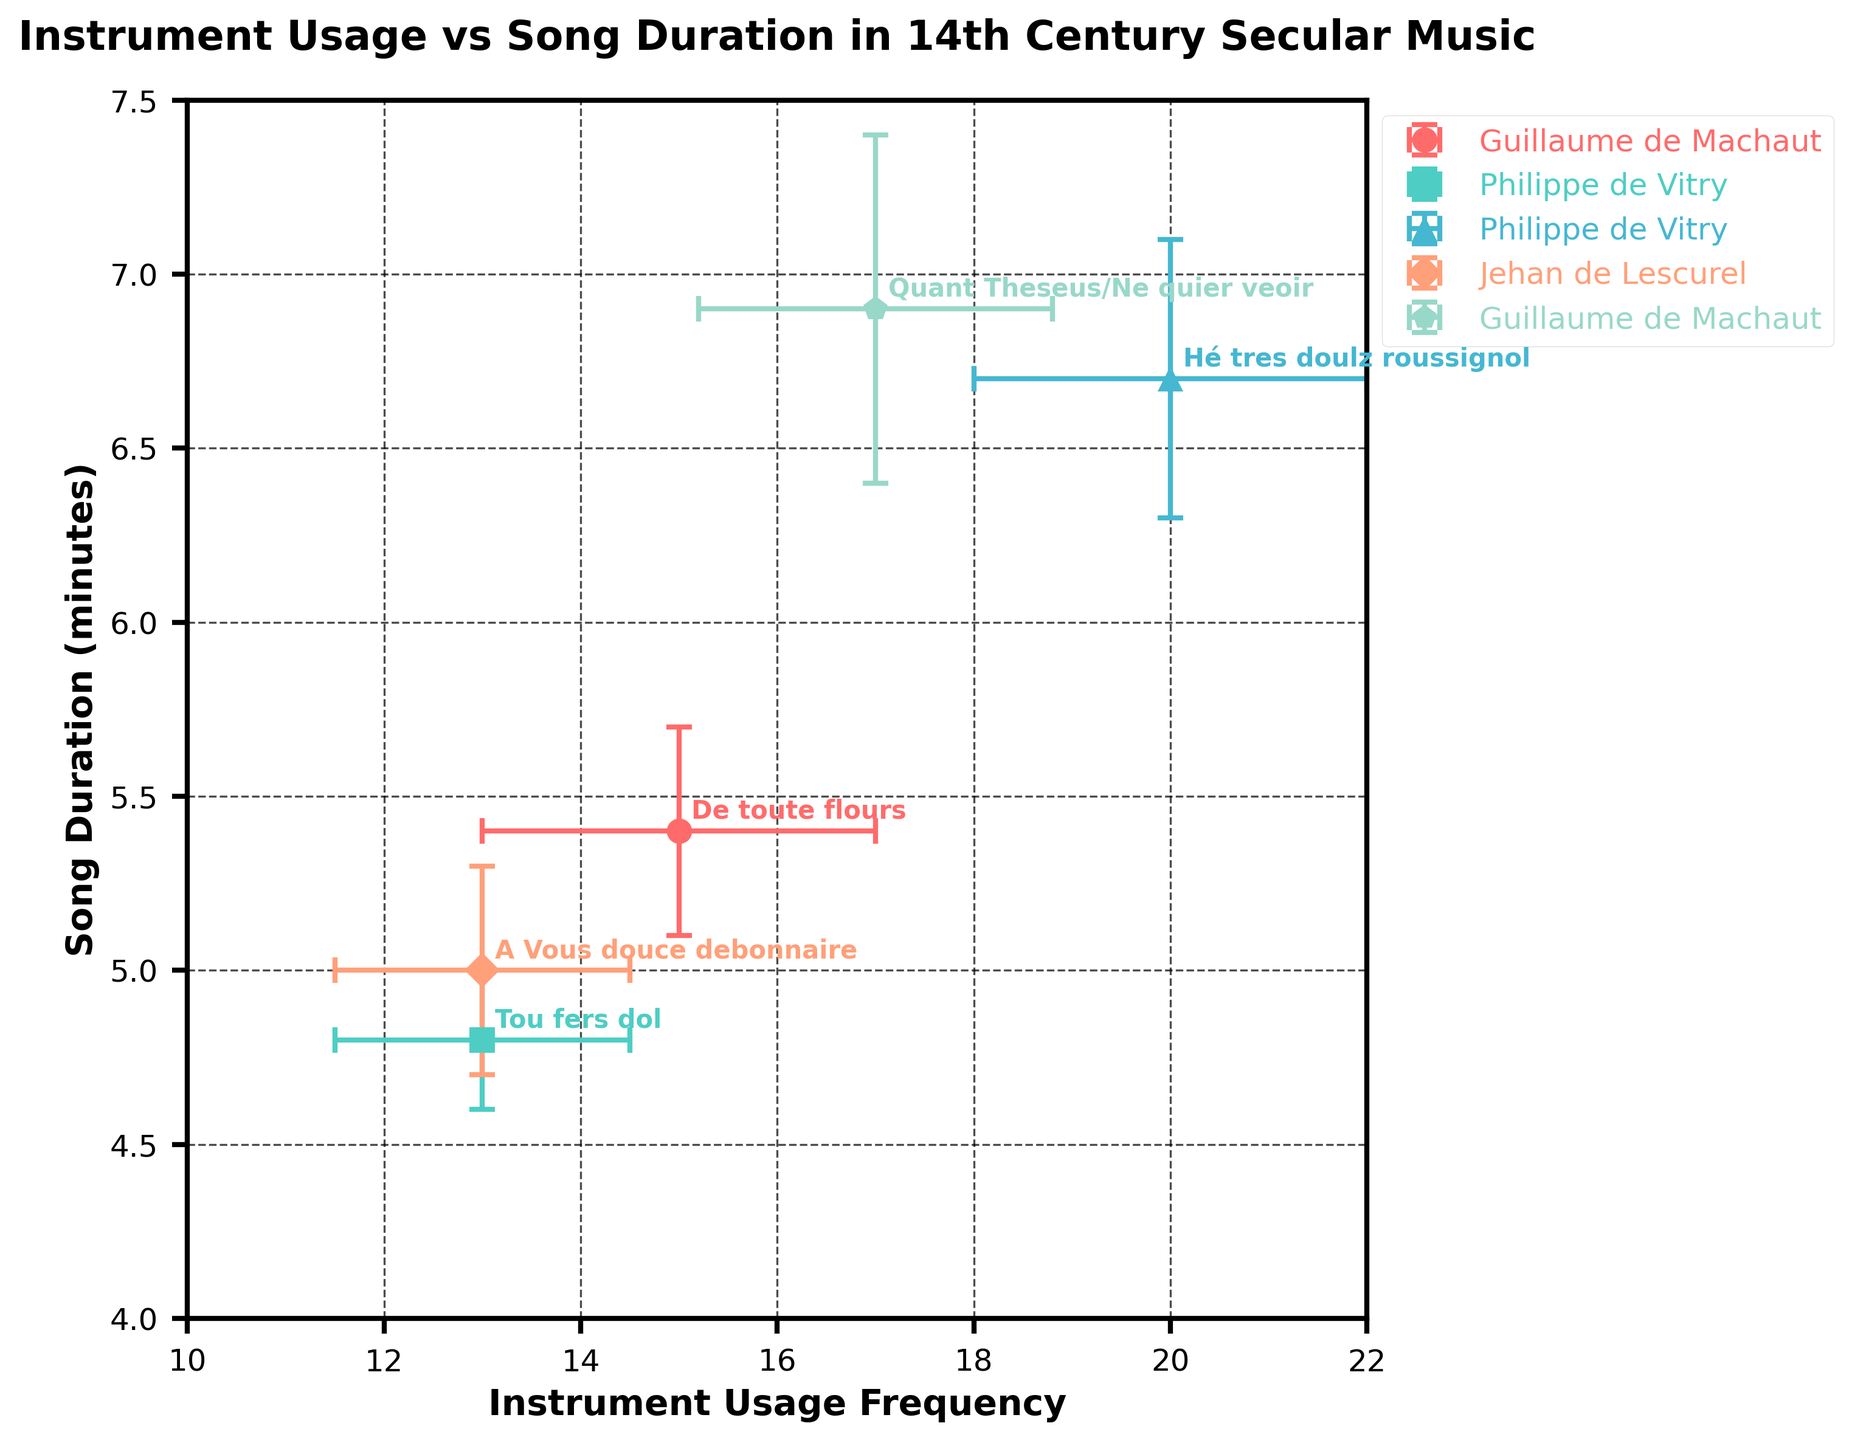How many data points are shown in the figure? Count the number of distinct points in the scatter plot. Each point represents a different song.
Answer: 5 Which composer's song has the highest instrument usage frequency? Identify the data point with the highest x-axis value and check the composer label associated with it.
Answer: Philippe de Vitry What is the title of Guillaume de Machaut's song with the lowest duration? Locate the data points for Guillaume de Machaut and compare the y-axis values to find the lowest one, then check the title label.
Answer: De toute flours What is the range of the song durations shown in the figure? Find the minimum and maximum values on the y-axis for the song duration and subtract the minimum from the maximum to get the range.
Answer: 2.1 Is there any song with an instrument usage frequency between 16 and 18? Check the x-axis values to see if any data point falls within the range of 16 to 18.
Answer: Yes Which song has the smallest error margin in instrument usage frequency? Identify the data point with the smallest error bar on the x-axis.
Answer: Tou fers dol Compare the song duration errors of songs composed by Philippe de Vitry. Which one has a larger error margin? Locate the data points for Philippe de Vitry, then compare the lengths of the error bars on the y-axis for each.
Answer: Hé tres doulz roussignol Which composer’s songs appear at both the lower and higher ends of instrument usage frequency? Check the data points for variability in the x-axis values for each composer.
Answer: Philippe de Vitry For Jehan de Lescurel, what is the sum of his song's duration and its error margin? Locate the data point for Jehan de Lescurel, add the song duration value and its error margin.
Answer: 5.3 Average the song durations of all compositions by Guillaume de Machaut. Locate the data points for Guillaume de Machaut, sum their y-axis values, and divide by the number of songs.
Answer: 6.15 